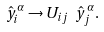Convert formula to latex. <formula><loc_0><loc_0><loc_500><loc_500>\hat { y } ^ { \alpha } _ { i } \rightarrow U _ { i j } \ \hat { y } ^ { \alpha } _ { j } .</formula> 